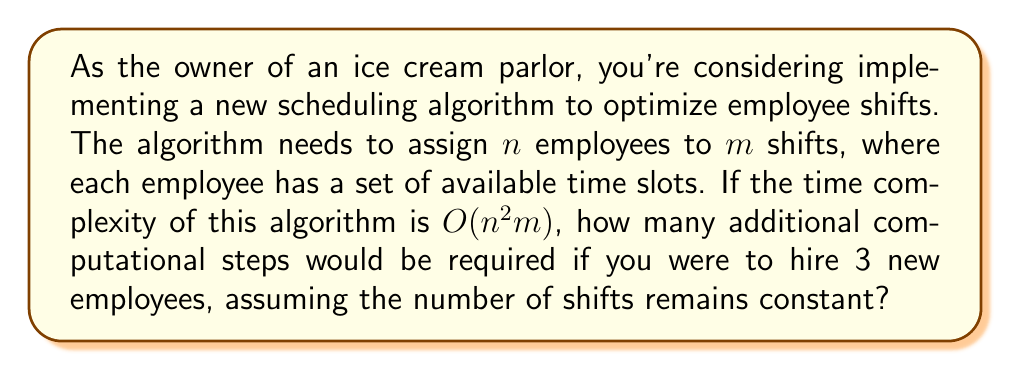What is the answer to this math problem? Let's break this down step-by-step:

1) The given time complexity is $O(n^2m)$, where $n$ is the number of employees and $m$ is the number of shifts.

2) Let's say the current number of employees is $x$. Then the current time complexity can be expressed as $kx^2m$, where $k$ is some constant.

3) If we add 3 new employees, the new number of employees will be $x+3$.

4) The new time complexity will be $k(x+3)^2m$.

5) To find the additional computational steps, we need to subtract the old complexity from the new complexity:

   $k(x+3)^2m - kx^2m$

6) Let's expand this:

   $k(x^2 + 6x + 9)m - kx^2m$
   $= kx^2m + 6kxm + 9km - kx^2m$
   $= 6kxm + 9km$

7) This simplifies to $3km(2x + 3)$

8) Therefore, the additional computational steps are proportional to $3km(2x + 3)$, where $x$ is the original number of employees, $m$ is the number of shifts, and $k$ is a constant factor.
Answer: The additional computational steps required are proportional to $3km(2x + 3)$, where $x$ is the original number of employees, $m$ is the number of shifts, and $k$ is a constant factor. 